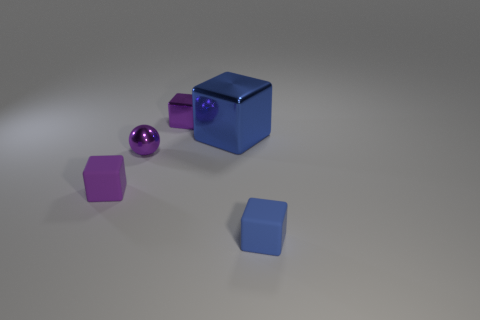Subtract all blue cylinders. How many purple blocks are left? 2 Subtract all small blocks. How many blocks are left? 1 Subtract all blocks. How many objects are left? 1 Add 1 blue metallic cubes. How many objects exist? 6 Add 2 big gray metal cylinders. How many big gray metal cylinders exist? 2 Subtract 0 yellow cubes. How many objects are left? 5 Subtract all red blocks. Subtract all red cylinders. How many blocks are left? 4 Subtract all small blue spheres. Subtract all tiny shiny spheres. How many objects are left? 4 Add 5 large blue things. How many large blue things are left? 6 